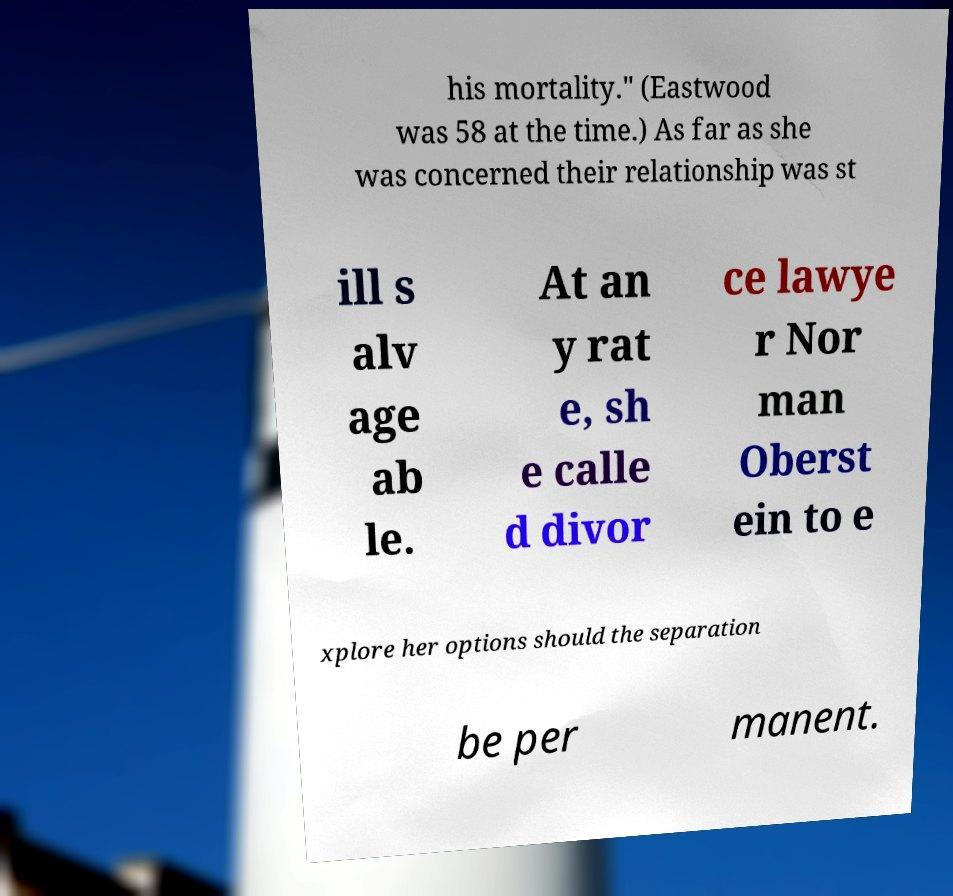What messages or text are displayed in this image? I need them in a readable, typed format. his mortality." (Eastwood was 58 at the time.) As far as she was concerned their relationship was st ill s alv age ab le. At an y rat e, sh e calle d divor ce lawye r Nor man Oberst ein to e xplore her options should the separation be per manent. 